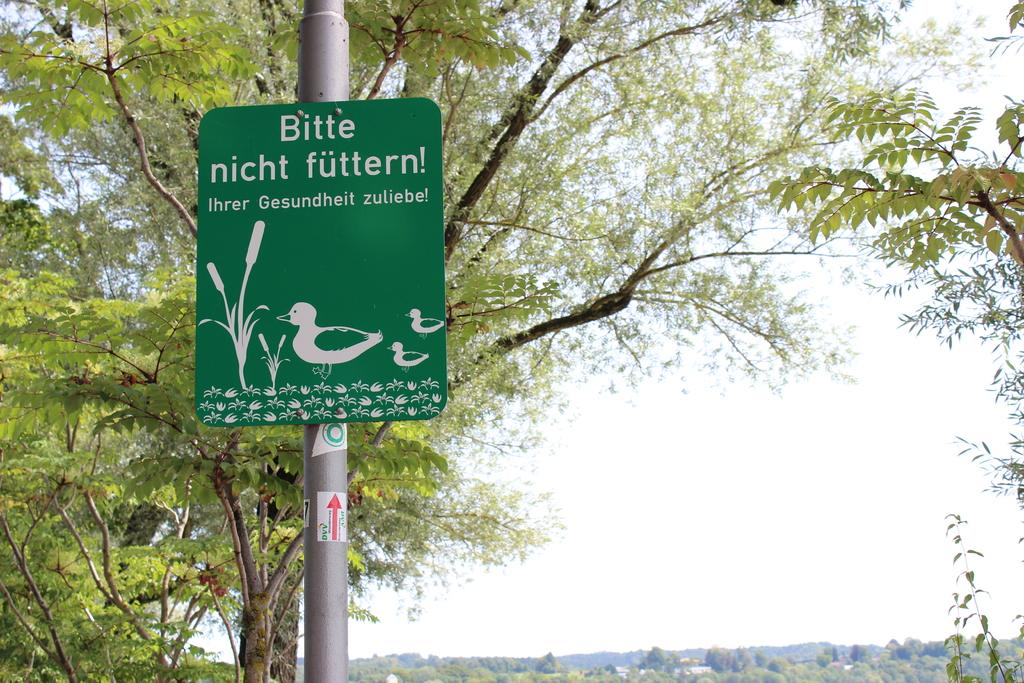What is the main object in the image? There is a green color board in the image. How is the color board positioned in the image? The board is fixed to a pole. What can be found on the color board? There is text on the board. What type of natural scenery is visible in the image? There are trees visible in the image. What can be seen in the background of the image? The sky is visible in the background of the image. What is the aftermath of the expert's pump failure in the image? There is no expert, pump, or any indication of a pump failure in the image. 